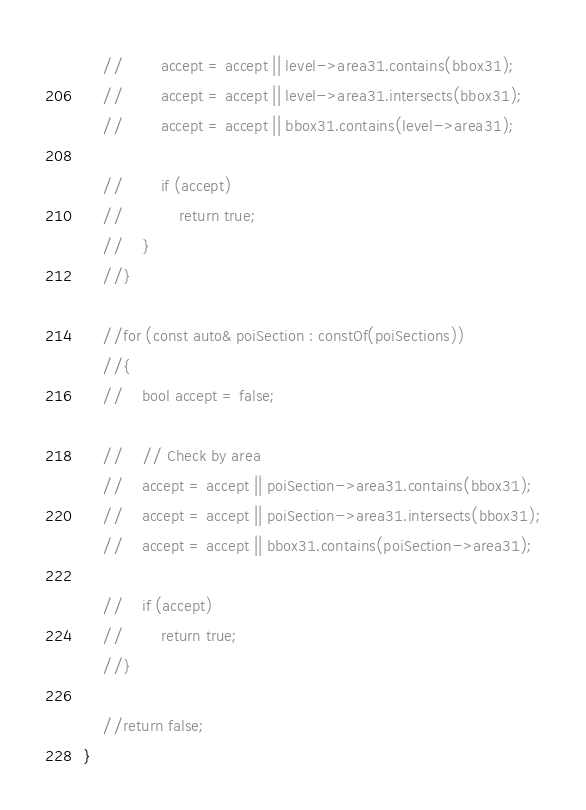Convert code to text. <code><loc_0><loc_0><loc_500><loc_500><_C++_>    //        accept = accept || level->area31.contains(bbox31);
    //        accept = accept || level->area31.intersects(bbox31);
    //        accept = accept || bbox31.contains(level->area31);

    //        if (accept)
    //            return true;
    //    }
    //}

    //for (const auto& poiSection : constOf(poiSections))
    //{
    //    bool accept = false;

    //    // Check by area
    //    accept = accept || poiSection->area31.contains(bbox31);
    //    accept = accept || poiSection->area31.intersects(bbox31);
    //    accept = accept || bbox31.contains(poiSection->area31);

    //    if (accept)
    //        return true;
    //}

    //return false;
}
</code> 